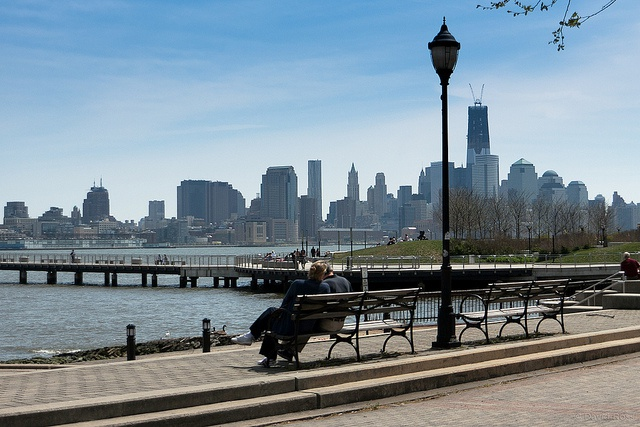Describe the objects in this image and their specific colors. I can see bench in lightblue, black, gray, darkgray, and ivory tones, bench in lightblue, black, darkgray, gray, and lightgray tones, people in lightblue, black, gray, and darkgray tones, people in lightblue, black, and gray tones, and people in lightblue, black, gray, darkgray, and darkgreen tones in this image. 